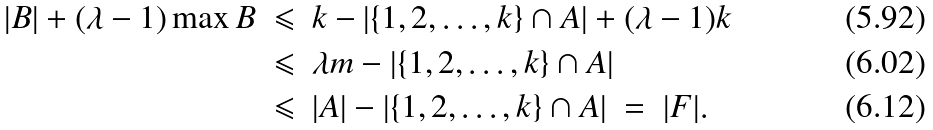Convert formula to latex. <formula><loc_0><loc_0><loc_500><loc_500>| B | + ( \lambda - 1 ) \max B & \ \leqslant \ k - | \{ 1 , 2 , \dots , k \} \cap A | + ( \lambda - 1 ) k \\ & \ \leqslant \ \lambda m - | \{ 1 , 2 , \dots , k \} \cap A | \\ & \ \leqslant \ | A | - | \{ 1 , 2 , \dots , k \} \cap A | \ = \ | F | .</formula> 